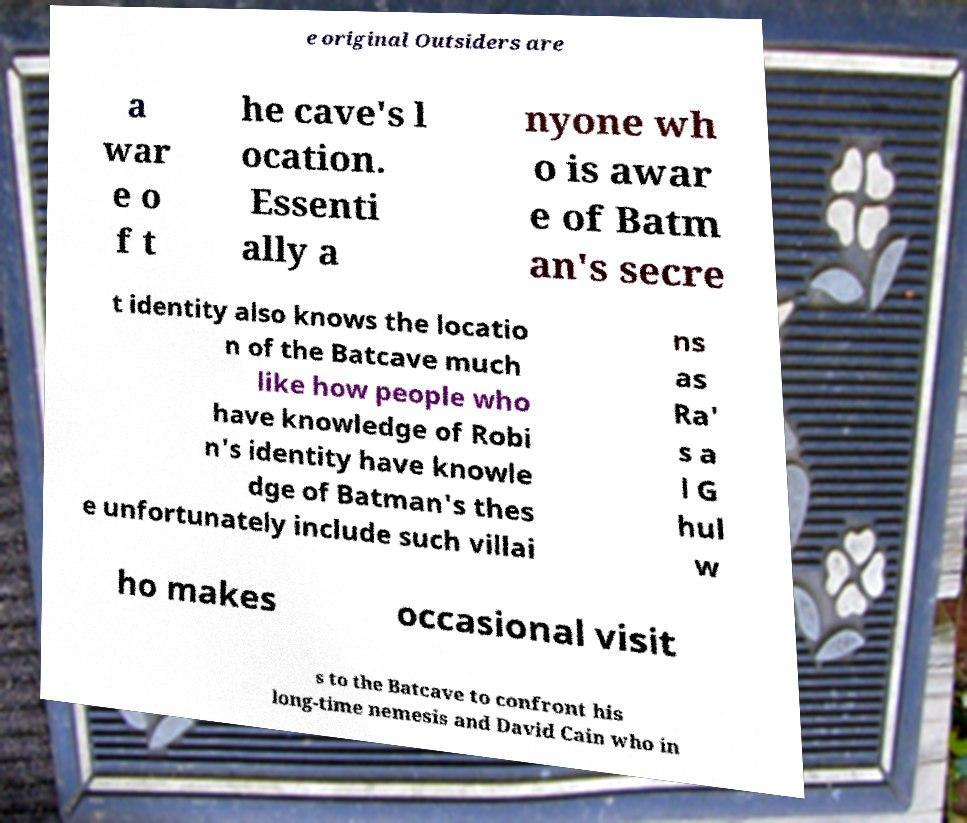What messages or text are displayed in this image? I need them in a readable, typed format. e original Outsiders are a war e o f t he cave's l ocation. Essenti ally a nyone wh o is awar e of Batm an's secre t identity also knows the locatio n of the Batcave much like how people who have knowledge of Robi n's identity have knowle dge of Batman's thes e unfortunately include such villai ns as Ra' s a l G hul w ho makes occasional visit s to the Batcave to confront his long-time nemesis and David Cain who in 